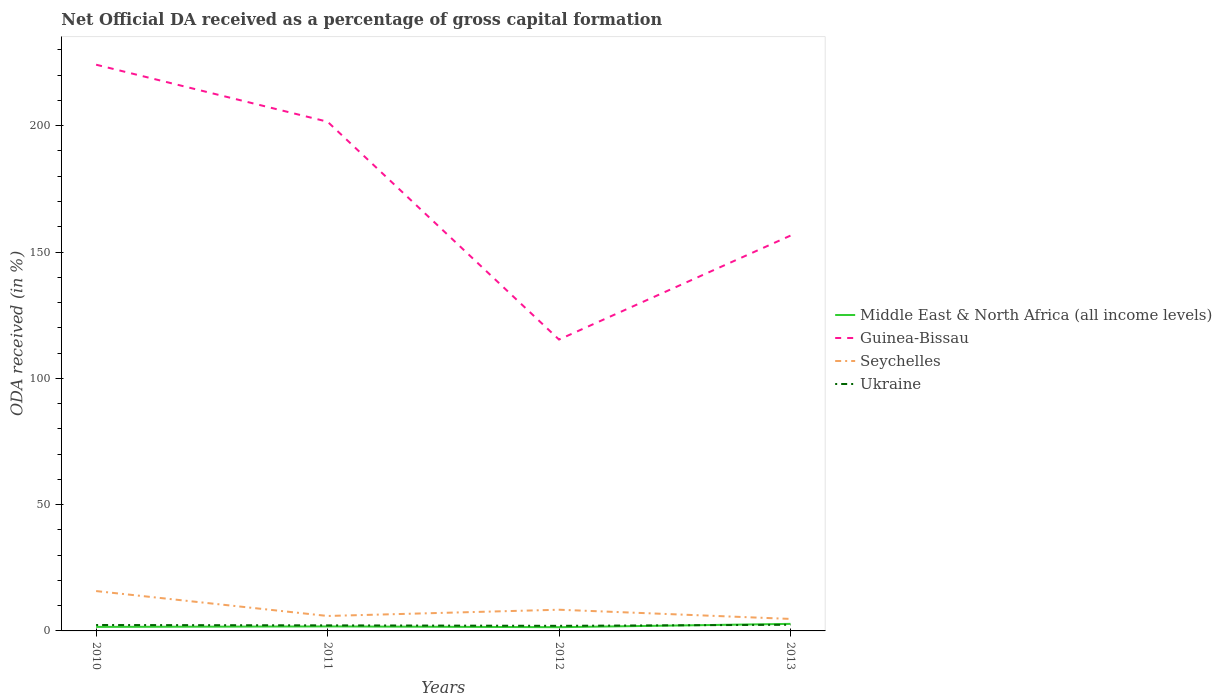Across all years, what is the maximum net ODA received in Ukraine?
Provide a short and direct response. 2.02. In which year was the net ODA received in Seychelles maximum?
Offer a terse response. 2013. What is the total net ODA received in Seychelles in the graph?
Make the answer very short. 1.17. What is the difference between the highest and the second highest net ODA received in Seychelles?
Provide a succinct answer. 11.03. How many years are there in the graph?
Provide a succinct answer. 4. Are the values on the major ticks of Y-axis written in scientific E-notation?
Ensure brevity in your answer.  No. Does the graph contain grids?
Provide a succinct answer. No. How are the legend labels stacked?
Keep it short and to the point. Vertical. What is the title of the graph?
Your response must be concise. Net Official DA received as a percentage of gross capital formation. Does "Tanzania" appear as one of the legend labels in the graph?
Give a very brief answer. No. What is the label or title of the X-axis?
Offer a terse response. Years. What is the label or title of the Y-axis?
Give a very brief answer. ODA received (in %). What is the ODA received (in %) in Middle East & North Africa (all income levels) in 2010?
Your response must be concise. 1.59. What is the ODA received (in %) of Guinea-Bissau in 2010?
Give a very brief answer. 224.17. What is the ODA received (in %) in Seychelles in 2010?
Make the answer very short. 15.78. What is the ODA received (in %) in Ukraine in 2010?
Offer a terse response. 2.35. What is the ODA received (in %) in Middle East & North Africa (all income levels) in 2011?
Ensure brevity in your answer.  1.78. What is the ODA received (in %) in Guinea-Bissau in 2011?
Provide a succinct answer. 201.59. What is the ODA received (in %) in Seychelles in 2011?
Your response must be concise. 5.92. What is the ODA received (in %) of Ukraine in 2011?
Provide a short and direct response. 2.2. What is the ODA received (in %) of Middle East & North Africa (all income levels) in 2012?
Your answer should be very brief. 1.48. What is the ODA received (in %) of Guinea-Bissau in 2012?
Your response must be concise. 115.35. What is the ODA received (in %) in Seychelles in 2012?
Keep it short and to the point. 8.39. What is the ODA received (in %) of Ukraine in 2012?
Your answer should be compact. 2.02. What is the ODA received (in %) in Middle East & North Africa (all income levels) in 2013?
Offer a very short reply. 2.79. What is the ODA received (in %) in Guinea-Bissau in 2013?
Provide a succinct answer. 156.5. What is the ODA received (in %) in Seychelles in 2013?
Make the answer very short. 4.75. What is the ODA received (in %) in Ukraine in 2013?
Make the answer very short. 2.44. Across all years, what is the maximum ODA received (in %) of Middle East & North Africa (all income levels)?
Provide a short and direct response. 2.79. Across all years, what is the maximum ODA received (in %) of Guinea-Bissau?
Offer a terse response. 224.17. Across all years, what is the maximum ODA received (in %) of Seychelles?
Your answer should be compact. 15.78. Across all years, what is the maximum ODA received (in %) of Ukraine?
Provide a short and direct response. 2.44. Across all years, what is the minimum ODA received (in %) of Middle East & North Africa (all income levels)?
Keep it short and to the point. 1.48. Across all years, what is the minimum ODA received (in %) of Guinea-Bissau?
Your response must be concise. 115.35. Across all years, what is the minimum ODA received (in %) of Seychelles?
Ensure brevity in your answer.  4.75. Across all years, what is the minimum ODA received (in %) in Ukraine?
Your response must be concise. 2.02. What is the total ODA received (in %) in Middle East & North Africa (all income levels) in the graph?
Give a very brief answer. 7.63. What is the total ODA received (in %) of Guinea-Bissau in the graph?
Provide a succinct answer. 697.6. What is the total ODA received (in %) of Seychelles in the graph?
Give a very brief answer. 34.84. What is the total ODA received (in %) in Ukraine in the graph?
Provide a short and direct response. 9. What is the difference between the ODA received (in %) of Middle East & North Africa (all income levels) in 2010 and that in 2011?
Offer a terse response. -0.19. What is the difference between the ODA received (in %) of Guinea-Bissau in 2010 and that in 2011?
Provide a succinct answer. 22.57. What is the difference between the ODA received (in %) of Seychelles in 2010 and that in 2011?
Your response must be concise. 9.86. What is the difference between the ODA received (in %) of Ukraine in 2010 and that in 2011?
Your response must be concise. 0.15. What is the difference between the ODA received (in %) of Middle East & North Africa (all income levels) in 2010 and that in 2012?
Provide a succinct answer. 0.11. What is the difference between the ODA received (in %) of Guinea-Bissau in 2010 and that in 2012?
Make the answer very short. 108.81. What is the difference between the ODA received (in %) in Seychelles in 2010 and that in 2012?
Your answer should be very brief. 7.38. What is the difference between the ODA received (in %) in Ukraine in 2010 and that in 2012?
Provide a short and direct response. 0.33. What is the difference between the ODA received (in %) in Middle East & North Africa (all income levels) in 2010 and that in 2013?
Offer a very short reply. -1.2. What is the difference between the ODA received (in %) of Guinea-Bissau in 2010 and that in 2013?
Keep it short and to the point. 67.67. What is the difference between the ODA received (in %) in Seychelles in 2010 and that in 2013?
Your response must be concise. 11.03. What is the difference between the ODA received (in %) in Ukraine in 2010 and that in 2013?
Your answer should be very brief. -0.09. What is the difference between the ODA received (in %) in Middle East & North Africa (all income levels) in 2011 and that in 2012?
Your answer should be very brief. 0.3. What is the difference between the ODA received (in %) in Guinea-Bissau in 2011 and that in 2012?
Offer a terse response. 86.24. What is the difference between the ODA received (in %) in Seychelles in 2011 and that in 2012?
Provide a short and direct response. -2.48. What is the difference between the ODA received (in %) of Ukraine in 2011 and that in 2012?
Your answer should be very brief. 0.19. What is the difference between the ODA received (in %) of Middle East & North Africa (all income levels) in 2011 and that in 2013?
Ensure brevity in your answer.  -1.01. What is the difference between the ODA received (in %) in Guinea-Bissau in 2011 and that in 2013?
Give a very brief answer. 45.1. What is the difference between the ODA received (in %) of Seychelles in 2011 and that in 2013?
Your response must be concise. 1.17. What is the difference between the ODA received (in %) in Ukraine in 2011 and that in 2013?
Ensure brevity in your answer.  -0.24. What is the difference between the ODA received (in %) of Middle East & North Africa (all income levels) in 2012 and that in 2013?
Provide a succinct answer. -1.31. What is the difference between the ODA received (in %) in Guinea-Bissau in 2012 and that in 2013?
Ensure brevity in your answer.  -41.15. What is the difference between the ODA received (in %) of Seychelles in 2012 and that in 2013?
Make the answer very short. 3.64. What is the difference between the ODA received (in %) of Ukraine in 2012 and that in 2013?
Your answer should be compact. -0.43. What is the difference between the ODA received (in %) of Middle East & North Africa (all income levels) in 2010 and the ODA received (in %) of Guinea-Bissau in 2011?
Offer a terse response. -200. What is the difference between the ODA received (in %) of Middle East & North Africa (all income levels) in 2010 and the ODA received (in %) of Seychelles in 2011?
Offer a very short reply. -4.33. What is the difference between the ODA received (in %) in Middle East & North Africa (all income levels) in 2010 and the ODA received (in %) in Ukraine in 2011?
Ensure brevity in your answer.  -0.61. What is the difference between the ODA received (in %) in Guinea-Bissau in 2010 and the ODA received (in %) in Seychelles in 2011?
Keep it short and to the point. 218.25. What is the difference between the ODA received (in %) in Guinea-Bissau in 2010 and the ODA received (in %) in Ukraine in 2011?
Give a very brief answer. 221.96. What is the difference between the ODA received (in %) in Seychelles in 2010 and the ODA received (in %) in Ukraine in 2011?
Offer a terse response. 13.57. What is the difference between the ODA received (in %) of Middle East & North Africa (all income levels) in 2010 and the ODA received (in %) of Guinea-Bissau in 2012?
Your answer should be very brief. -113.76. What is the difference between the ODA received (in %) in Middle East & North Africa (all income levels) in 2010 and the ODA received (in %) in Seychelles in 2012?
Give a very brief answer. -6.8. What is the difference between the ODA received (in %) of Middle East & North Africa (all income levels) in 2010 and the ODA received (in %) of Ukraine in 2012?
Provide a short and direct response. -0.43. What is the difference between the ODA received (in %) in Guinea-Bissau in 2010 and the ODA received (in %) in Seychelles in 2012?
Your answer should be very brief. 215.77. What is the difference between the ODA received (in %) of Guinea-Bissau in 2010 and the ODA received (in %) of Ukraine in 2012?
Provide a succinct answer. 222.15. What is the difference between the ODA received (in %) in Seychelles in 2010 and the ODA received (in %) in Ukraine in 2012?
Ensure brevity in your answer.  13.76. What is the difference between the ODA received (in %) of Middle East & North Africa (all income levels) in 2010 and the ODA received (in %) of Guinea-Bissau in 2013?
Your response must be concise. -154.91. What is the difference between the ODA received (in %) in Middle East & North Africa (all income levels) in 2010 and the ODA received (in %) in Seychelles in 2013?
Your response must be concise. -3.16. What is the difference between the ODA received (in %) in Middle East & North Africa (all income levels) in 2010 and the ODA received (in %) in Ukraine in 2013?
Provide a short and direct response. -0.85. What is the difference between the ODA received (in %) of Guinea-Bissau in 2010 and the ODA received (in %) of Seychelles in 2013?
Your answer should be very brief. 219.42. What is the difference between the ODA received (in %) in Guinea-Bissau in 2010 and the ODA received (in %) in Ukraine in 2013?
Offer a very short reply. 221.72. What is the difference between the ODA received (in %) of Seychelles in 2010 and the ODA received (in %) of Ukraine in 2013?
Your response must be concise. 13.33. What is the difference between the ODA received (in %) in Middle East & North Africa (all income levels) in 2011 and the ODA received (in %) in Guinea-Bissau in 2012?
Your answer should be compact. -113.57. What is the difference between the ODA received (in %) of Middle East & North Africa (all income levels) in 2011 and the ODA received (in %) of Seychelles in 2012?
Make the answer very short. -6.61. What is the difference between the ODA received (in %) in Middle East & North Africa (all income levels) in 2011 and the ODA received (in %) in Ukraine in 2012?
Ensure brevity in your answer.  -0.24. What is the difference between the ODA received (in %) in Guinea-Bissau in 2011 and the ODA received (in %) in Seychelles in 2012?
Provide a short and direct response. 193.2. What is the difference between the ODA received (in %) of Guinea-Bissau in 2011 and the ODA received (in %) of Ukraine in 2012?
Make the answer very short. 199.58. What is the difference between the ODA received (in %) in Seychelles in 2011 and the ODA received (in %) in Ukraine in 2012?
Provide a succinct answer. 3.9. What is the difference between the ODA received (in %) in Middle East & North Africa (all income levels) in 2011 and the ODA received (in %) in Guinea-Bissau in 2013?
Offer a very short reply. -154.72. What is the difference between the ODA received (in %) in Middle East & North Africa (all income levels) in 2011 and the ODA received (in %) in Seychelles in 2013?
Make the answer very short. -2.97. What is the difference between the ODA received (in %) of Middle East & North Africa (all income levels) in 2011 and the ODA received (in %) of Ukraine in 2013?
Ensure brevity in your answer.  -0.66. What is the difference between the ODA received (in %) in Guinea-Bissau in 2011 and the ODA received (in %) in Seychelles in 2013?
Make the answer very short. 196.84. What is the difference between the ODA received (in %) in Guinea-Bissau in 2011 and the ODA received (in %) in Ukraine in 2013?
Make the answer very short. 199.15. What is the difference between the ODA received (in %) in Seychelles in 2011 and the ODA received (in %) in Ukraine in 2013?
Your answer should be very brief. 3.48. What is the difference between the ODA received (in %) in Middle East & North Africa (all income levels) in 2012 and the ODA received (in %) in Guinea-Bissau in 2013?
Keep it short and to the point. -155.02. What is the difference between the ODA received (in %) of Middle East & North Africa (all income levels) in 2012 and the ODA received (in %) of Seychelles in 2013?
Offer a terse response. -3.27. What is the difference between the ODA received (in %) of Middle East & North Africa (all income levels) in 2012 and the ODA received (in %) of Ukraine in 2013?
Offer a terse response. -0.96. What is the difference between the ODA received (in %) in Guinea-Bissau in 2012 and the ODA received (in %) in Seychelles in 2013?
Ensure brevity in your answer.  110.6. What is the difference between the ODA received (in %) in Guinea-Bissau in 2012 and the ODA received (in %) in Ukraine in 2013?
Offer a terse response. 112.91. What is the difference between the ODA received (in %) in Seychelles in 2012 and the ODA received (in %) in Ukraine in 2013?
Your answer should be very brief. 5.95. What is the average ODA received (in %) of Middle East & North Africa (all income levels) per year?
Your response must be concise. 1.91. What is the average ODA received (in %) in Guinea-Bissau per year?
Provide a succinct answer. 174.4. What is the average ODA received (in %) in Seychelles per year?
Provide a short and direct response. 8.71. What is the average ODA received (in %) in Ukraine per year?
Offer a very short reply. 2.25. In the year 2010, what is the difference between the ODA received (in %) in Middle East & North Africa (all income levels) and ODA received (in %) in Guinea-Bissau?
Provide a succinct answer. -222.58. In the year 2010, what is the difference between the ODA received (in %) of Middle East & North Africa (all income levels) and ODA received (in %) of Seychelles?
Offer a terse response. -14.19. In the year 2010, what is the difference between the ODA received (in %) in Middle East & North Africa (all income levels) and ODA received (in %) in Ukraine?
Keep it short and to the point. -0.76. In the year 2010, what is the difference between the ODA received (in %) in Guinea-Bissau and ODA received (in %) in Seychelles?
Provide a short and direct response. 208.39. In the year 2010, what is the difference between the ODA received (in %) of Guinea-Bissau and ODA received (in %) of Ukraine?
Keep it short and to the point. 221.82. In the year 2010, what is the difference between the ODA received (in %) of Seychelles and ODA received (in %) of Ukraine?
Your response must be concise. 13.43. In the year 2011, what is the difference between the ODA received (in %) in Middle East & North Africa (all income levels) and ODA received (in %) in Guinea-Bissau?
Keep it short and to the point. -199.81. In the year 2011, what is the difference between the ODA received (in %) in Middle East & North Africa (all income levels) and ODA received (in %) in Seychelles?
Make the answer very short. -4.14. In the year 2011, what is the difference between the ODA received (in %) in Middle East & North Africa (all income levels) and ODA received (in %) in Ukraine?
Your response must be concise. -0.42. In the year 2011, what is the difference between the ODA received (in %) in Guinea-Bissau and ODA received (in %) in Seychelles?
Keep it short and to the point. 195.67. In the year 2011, what is the difference between the ODA received (in %) of Guinea-Bissau and ODA received (in %) of Ukraine?
Offer a very short reply. 199.39. In the year 2011, what is the difference between the ODA received (in %) in Seychelles and ODA received (in %) in Ukraine?
Your response must be concise. 3.72. In the year 2012, what is the difference between the ODA received (in %) of Middle East & North Africa (all income levels) and ODA received (in %) of Guinea-Bissau?
Offer a very short reply. -113.87. In the year 2012, what is the difference between the ODA received (in %) of Middle East & North Africa (all income levels) and ODA received (in %) of Seychelles?
Give a very brief answer. -6.92. In the year 2012, what is the difference between the ODA received (in %) of Middle East & North Africa (all income levels) and ODA received (in %) of Ukraine?
Offer a very short reply. -0.54. In the year 2012, what is the difference between the ODA received (in %) of Guinea-Bissau and ODA received (in %) of Seychelles?
Your answer should be very brief. 106.96. In the year 2012, what is the difference between the ODA received (in %) of Guinea-Bissau and ODA received (in %) of Ukraine?
Provide a succinct answer. 113.34. In the year 2012, what is the difference between the ODA received (in %) of Seychelles and ODA received (in %) of Ukraine?
Your answer should be very brief. 6.38. In the year 2013, what is the difference between the ODA received (in %) in Middle East & North Africa (all income levels) and ODA received (in %) in Guinea-Bissau?
Make the answer very short. -153.71. In the year 2013, what is the difference between the ODA received (in %) in Middle East & North Africa (all income levels) and ODA received (in %) in Seychelles?
Your answer should be compact. -1.96. In the year 2013, what is the difference between the ODA received (in %) in Middle East & North Africa (all income levels) and ODA received (in %) in Ukraine?
Offer a terse response. 0.35. In the year 2013, what is the difference between the ODA received (in %) of Guinea-Bissau and ODA received (in %) of Seychelles?
Your answer should be compact. 151.75. In the year 2013, what is the difference between the ODA received (in %) in Guinea-Bissau and ODA received (in %) in Ukraine?
Keep it short and to the point. 154.06. In the year 2013, what is the difference between the ODA received (in %) in Seychelles and ODA received (in %) in Ukraine?
Make the answer very short. 2.31. What is the ratio of the ODA received (in %) of Middle East & North Africa (all income levels) in 2010 to that in 2011?
Your answer should be very brief. 0.89. What is the ratio of the ODA received (in %) of Guinea-Bissau in 2010 to that in 2011?
Offer a very short reply. 1.11. What is the ratio of the ODA received (in %) in Seychelles in 2010 to that in 2011?
Give a very brief answer. 2.67. What is the ratio of the ODA received (in %) in Ukraine in 2010 to that in 2011?
Offer a very short reply. 1.07. What is the ratio of the ODA received (in %) in Middle East & North Africa (all income levels) in 2010 to that in 2012?
Your answer should be very brief. 1.08. What is the ratio of the ODA received (in %) of Guinea-Bissau in 2010 to that in 2012?
Provide a short and direct response. 1.94. What is the ratio of the ODA received (in %) in Seychelles in 2010 to that in 2012?
Keep it short and to the point. 1.88. What is the ratio of the ODA received (in %) of Ukraine in 2010 to that in 2012?
Make the answer very short. 1.16. What is the ratio of the ODA received (in %) in Middle East & North Africa (all income levels) in 2010 to that in 2013?
Provide a short and direct response. 0.57. What is the ratio of the ODA received (in %) in Guinea-Bissau in 2010 to that in 2013?
Your answer should be very brief. 1.43. What is the ratio of the ODA received (in %) of Seychelles in 2010 to that in 2013?
Keep it short and to the point. 3.32. What is the ratio of the ODA received (in %) in Ukraine in 2010 to that in 2013?
Make the answer very short. 0.96. What is the ratio of the ODA received (in %) of Middle East & North Africa (all income levels) in 2011 to that in 2012?
Ensure brevity in your answer.  1.21. What is the ratio of the ODA received (in %) in Guinea-Bissau in 2011 to that in 2012?
Provide a succinct answer. 1.75. What is the ratio of the ODA received (in %) of Seychelles in 2011 to that in 2012?
Provide a short and direct response. 0.71. What is the ratio of the ODA received (in %) in Ukraine in 2011 to that in 2012?
Provide a short and direct response. 1.09. What is the ratio of the ODA received (in %) in Middle East & North Africa (all income levels) in 2011 to that in 2013?
Ensure brevity in your answer.  0.64. What is the ratio of the ODA received (in %) in Guinea-Bissau in 2011 to that in 2013?
Provide a succinct answer. 1.29. What is the ratio of the ODA received (in %) of Seychelles in 2011 to that in 2013?
Offer a terse response. 1.25. What is the ratio of the ODA received (in %) in Ukraine in 2011 to that in 2013?
Provide a short and direct response. 0.9. What is the ratio of the ODA received (in %) in Middle East & North Africa (all income levels) in 2012 to that in 2013?
Make the answer very short. 0.53. What is the ratio of the ODA received (in %) in Guinea-Bissau in 2012 to that in 2013?
Offer a very short reply. 0.74. What is the ratio of the ODA received (in %) in Seychelles in 2012 to that in 2013?
Offer a terse response. 1.77. What is the ratio of the ODA received (in %) in Ukraine in 2012 to that in 2013?
Offer a very short reply. 0.83. What is the difference between the highest and the second highest ODA received (in %) of Middle East & North Africa (all income levels)?
Keep it short and to the point. 1.01. What is the difference between the highest and the second highest ODA received (in %) in Guinea-Bissau?
Keep it short and to the point. 22.57. What is the difference between the highest and the second highest ODA received (in %) in Seychelles?
Your answer should be compact. 7.38. What is the difference between the highest and the second highest ODA received (in %) of Ukraine?
Ensure brevity in your answer.  0.09. What is the difference between the highest and the lowest ODA received (in %) of Middle East & North Africa (all income levels)?
Offer a very short reply. 1.31. What is the difference between the highest and the lowest ODA received (in %) of Guinea-Bissau?
Your response must be concise. 108.81. What is the difference between the highest and the lowest ODA received (in %) of Seychelles?
Keep it short and to the point. 11.03. What is the difference between the highest and the lowest ODA received (in %) of Ukraine?
Provide a succinct answer. 0.43. 